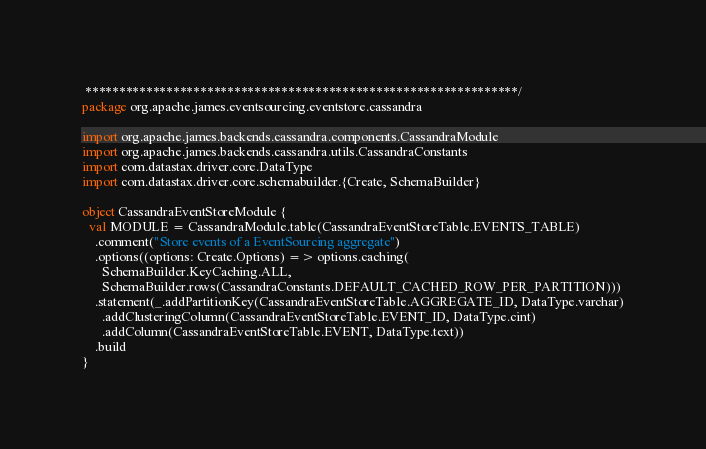<code> <loc_0><loc_0><loc_500><loc_500><_Scala_> ****************************************************************/
package org.apache.james.eventsourcing.eventstore.cassandra

import org.apache.james.backends.cassandra.components.CassandraModule
import org.apache.james.backends.cassandra.utils.CassandraConstants
import com.datastax.driver.core.DataType
import com.datastax.driver.core.schemabuilder.{Create, SchemaBuilder}

object CassandraEventStoreModule {
  val MODULE = CassandraModule.table(CassandraEventStoreTable.EVENTS_TABLE)
    .comment("Store events of a EventSourcing aggregate")
    .options((options: Create.Options) => options.caching(
      SchemaBuilder.KeyCaching.ALL,
      SchemaBuilder.rows(CassandraConstants.DEFAULT_CACHED_ROW_PER_PARTITION)))
    .statement(_.addPartitionKey(CassandraEventStoreTable.AGGREGATE_ID, DataType.varchar)
      .addClusteringColumn(CassandraEventStoreTable.EVENT_ID, DataType.cint)
      .addColumn(CassandraEventStoreTable.EVENT, DataType.text))
    .build
}</code> 